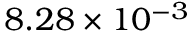<formula> <loc_0><loc_0><loc_500><loc_500>8 . 2 8 \times 1 0 ^ { - 3 }</formula> 